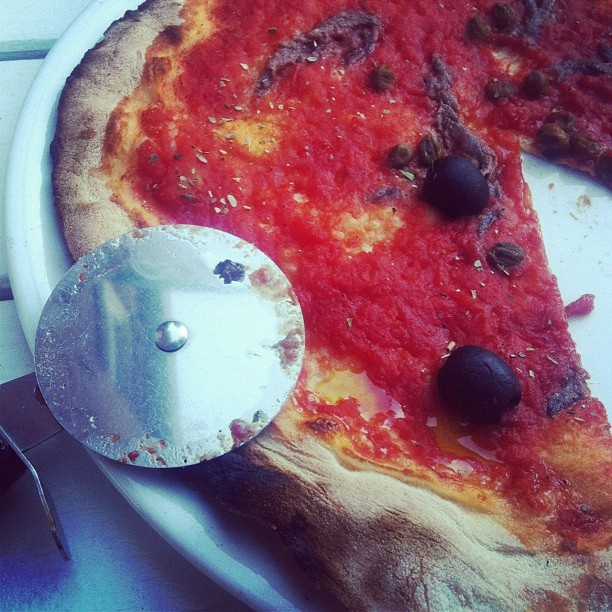Describe the objects in this image and their specific colors. I can see a pizza in lightblue, brown, and maroon tones in this image. 